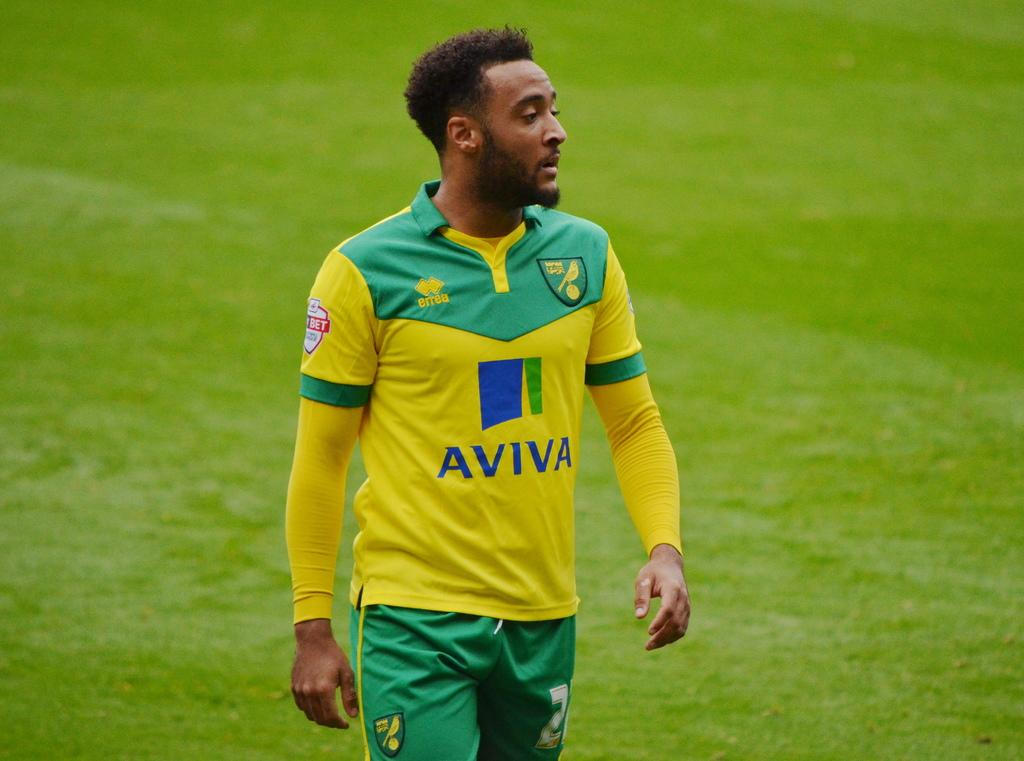<image>
Summarize the visual content of the image. A soccer player is wearing a yellow and green uniform with Aviva written on it. 